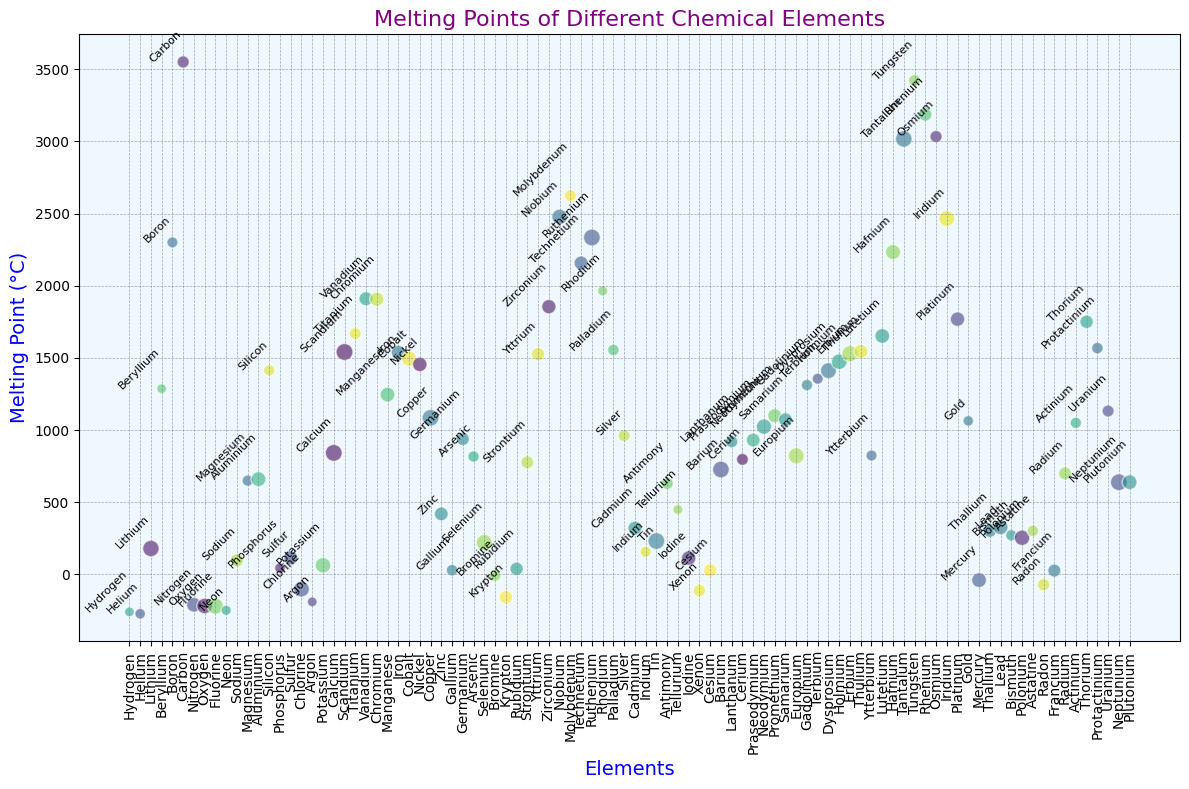What's the element with the highest melting point? The element with the highest melting point is the one plotted at the highest point on the y-axis. By observing the scatter plot, Carbon is positioned at the highest y-axis value at 3550 °C.
Answer: Carbon Which element has a lower melting point, Bromine or Iodine? To compare their melting points, find the positions of Bromine and Iodine on the y-axis. Bromine is at -7.2 °C, and Iodine is at 113.7 °C. Bromine is plotted lower on the y-axis than Iodine.
Answer: Bromine How many elements have a melting point above 1000 °C? To count the elements above this threshold, observe which points are plotted higher than 1000 °C on the y-axis. There are 40 such elements above this level.
Answer: 40 What's the average melting point of Hydrogen, Helium, and Neon? First, find the melting points of each element: Hydrogen (-259 °C), Helium (-272 °C), and Neon (-248 °C). Add them up (-259 + -272 + -248 = -779) and divide by the number of elements (3). The average is -779/3 = -259.7 °C.
Answer: -259.7 °C What is the difference in melting points between Phosphorus and Gallium? Find their melting points: Phosphorus (44.1 °C) and Gallium (29.8 °C). Subtract Gallium's melting point from Phosphorus's (44.1 - 29.8 = 14.3).
Answer: 14.3 °C Which element melts at a higher temperature, Gold or Platinum? Find the position of Gold and Platinum on the y-axis. Gold is at 1064 °C, and Platinum is at 1768.3 °C. Platinum is plotted higher on the y-axis than Gold.
Answer: Platinum Which element has a higher melting point, Silicon or Silver? Locate Silicon and Silver on the y-axis: Silicon is at 1414 °C, and Silver is at 961.8 °C. Silicon is plotted higher on the y-axis.
Answer: Silicon What is the ratio of the melting points between Titanium and Aluminium? Find their melting points: Titanium (1668 °C) and Aluminium (660.3 °C). Divide Titanium's melting point by Aluminium's (1668/660.3 ≈ 2.53).
Answer: 2.53 Which element has the most distinct color in the scatter plot? The most distinct color will be the most visually noticeable in comparison to others. The color information isn't numerically specified, however, based on a plot using a varied color map like viridis, one could notice elements with vivid colors like bright blue or yellow as distinct. Select one based on that color difference.
Answer: Subjective percepción (requires plot view) Compare the melting points of Scandium and Cobalt — which is higher? Identify their melting points: Scandium (1541 °C) and Cobalt (1495 °C). Scandium's value on the y-axis is higher.
Answer: Scandium What is the median melting point of the elements provided? Arrange the melting points from the lowest to the highest value, find the middle value. Since there are an even number of elements (92), the median will be the average of the 46th and 47th elements in the ordered list. Manganese (1246 °C) and Europium (822 °C), the average is (1246 + 822)/2 = 1034 °C.
Answer: 1034 °C 